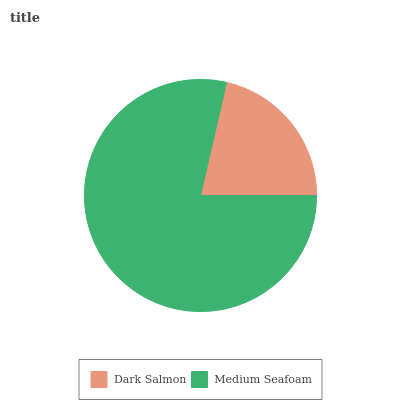Is Dark Salmon the minimum?
Answer yes or no. Yes. Is Medium Seafoam the maximum?
Answer yes or no. Yes. Is Medium Seafoam the minimum?
Answer yes or no. No. Is Medium Seafoam greater than Dark Salmon?
Answer yes or no. Yes. Is Dark Salmon less than Medium Seafoam?
Answer yes or no. Yes. Is Dark Salmon greater than Medium Seafoam?
Answer yes or no. No. Is Medium Seafoam less than Dark Salmon?
Answer yes or no. No. Is Medium Seafoam the high median?
Answer yes or no. Yes. Is Dark Salmon the low median?
Answer yes or no. Yes. Is Dark Salmon the high median?
Answer yes or no. No. Is Medium Seafoam the low median?
Answer yes or no. No. 